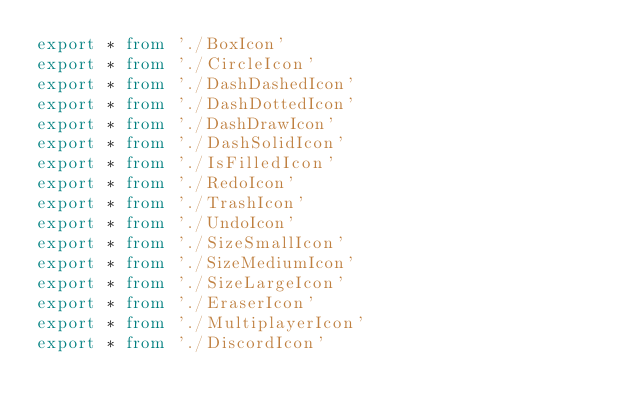<code> <loc_0><loc_0><loc_500><loc_500><_TypeScript_>export * from './BoxIcon'
export * from './CircleIcon'
export * from './DashDashedIcon'
export * from './DashDottedIcon'
export * from './DashDrawIcon'
export * from './DashSolidIcon'
export * from './IsFilledIcon'
export * from './RedoIcon'
export * from './TrashIcon'
export * from './UndoIcon'
export * from './SizeSmallIcon'
export * from './SizeMediumIcon'
export * from './SizeLargeIcon'
export * from './EraserIcon'
export * from './MultiplayerIcon'
export * from './DiscordIcon'
</code> 